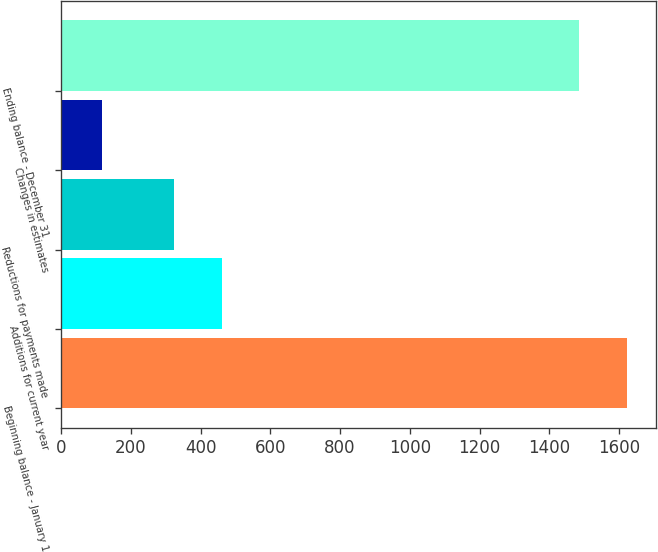<chart> <loc_0><loc_0><loc_500><loc_500><bar_chart><fcel>Beginning balance - January 1<fcel>Additions for current year<fcel>Reductions for payments made<fcel>Changes in estimates<fcel>Ending balance - December 31<nl><fcel>1623.7<fcel>461.7<fcel>323<fcel>117<fcel>1485<nl></chart> 